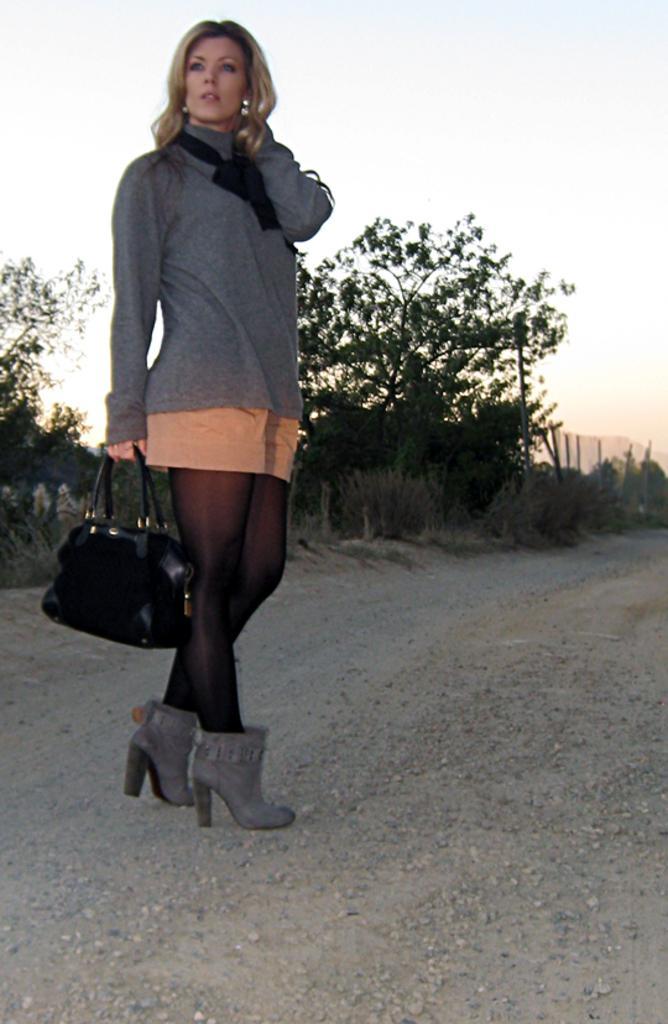Describe this image in one or two sentences. In this image I can see a woman is standing and holding a handbag. I can also see a road and few trees. 